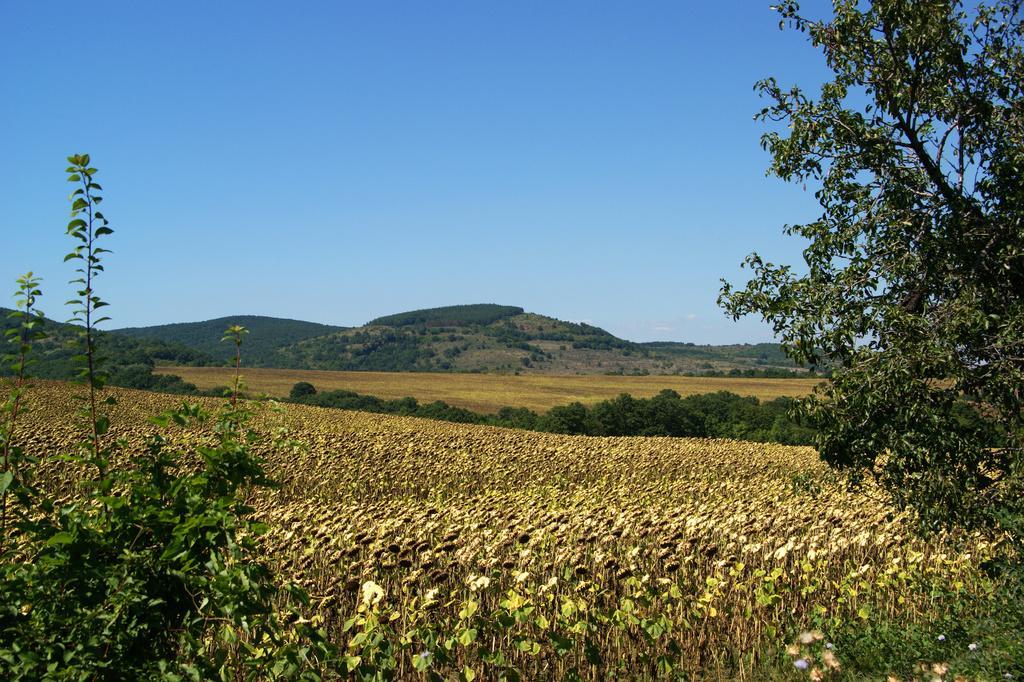How would you summarize this image in a sentence or two? In this picture there is greenery at the bottom side of the image. 